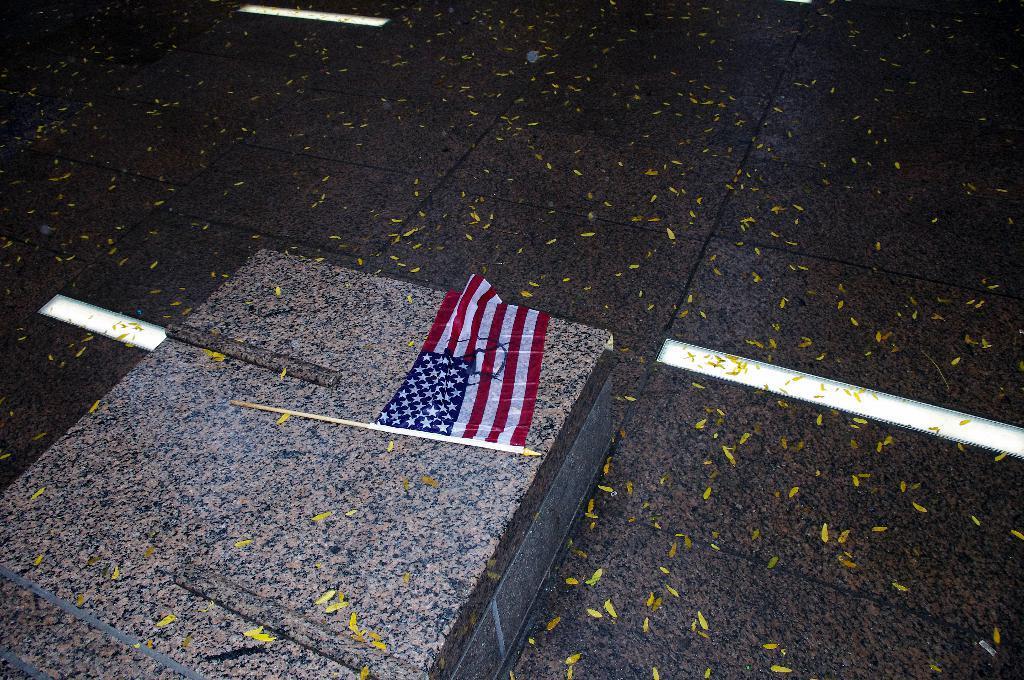Please provide a concise description of this image. In this image I can see a floor. And on the floor there is a marble. On the marble there is a flag tied to the stick. 